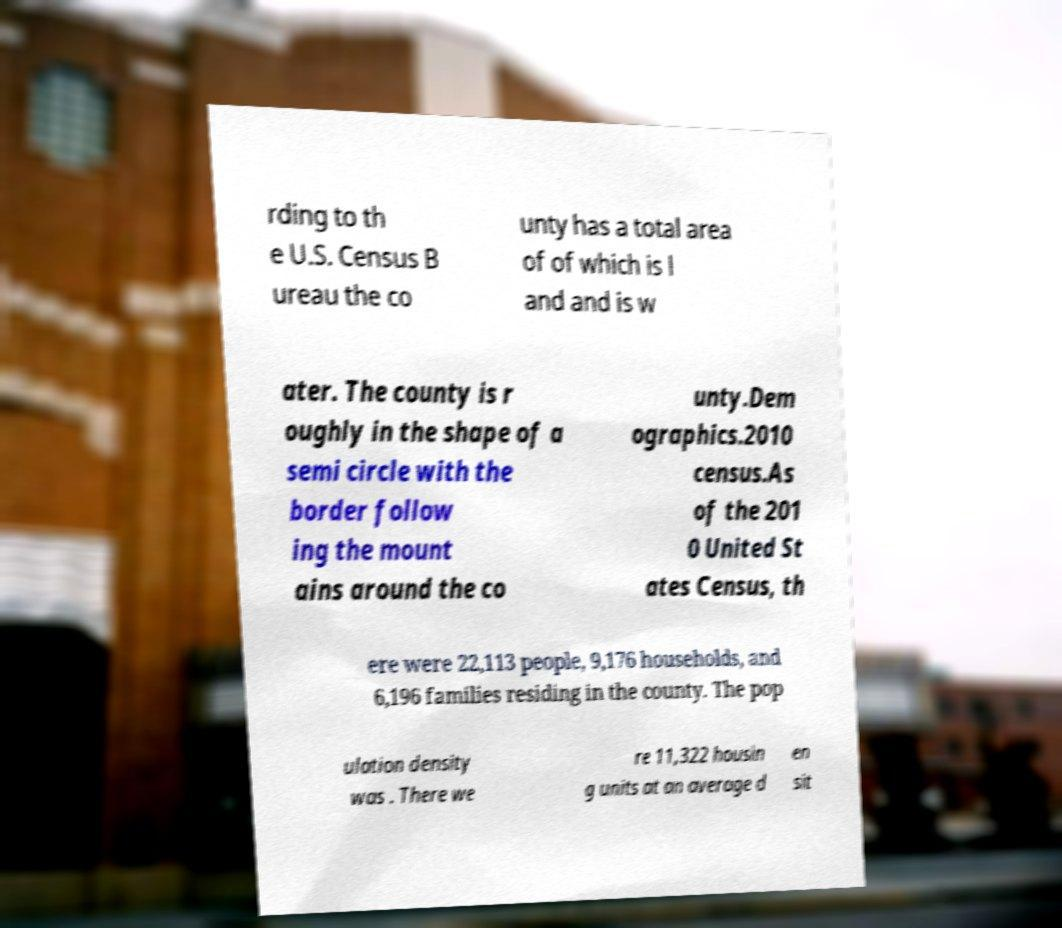Can you accurately transcribe the text from the provided image for me? rding to th e U.S. Census B ureau the co unty has a total area of of which is l and and is w ater. The county is r oughly in the shape of a semi circle with the border follow ing the mount ains around the co unty.Dem ographics.2010 census.As of the 201 0 United St ates Census, th ere were 22,113 people, 9,176 households, and 6,196 families residing in the county. The pop ulation density was . There we re 11,322 housin g units at an average d en sit 